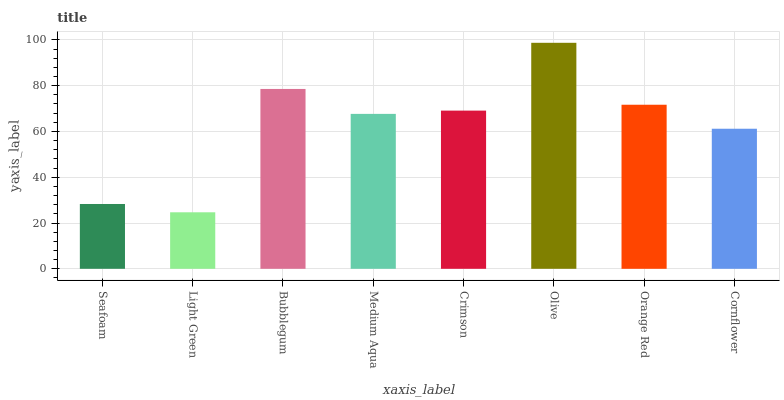Is Bubblegum the minimum?
Answer yes or no. No. Is Bubblegum the maximum?
Answer yes or no. No. Is Bubblegum greater than Light Green?
Answer yes or no. Yes. Is Light Green less than Bubblegum?
Answer yes or no. Yes. Is Light Green greater than Bubblegum?
Answer yes or no. No. Is Bubblegum less than Light Green?
Answer yes or no. No. Is Crimson the high median?
Answer yes or no. Yes. Is Medium Aqua the low median?
Answer yes or no. Yes. Is Bubblegum the high median?
Answer yes or no. No. Is Light Green the low median?
Answer yes or no. No. 